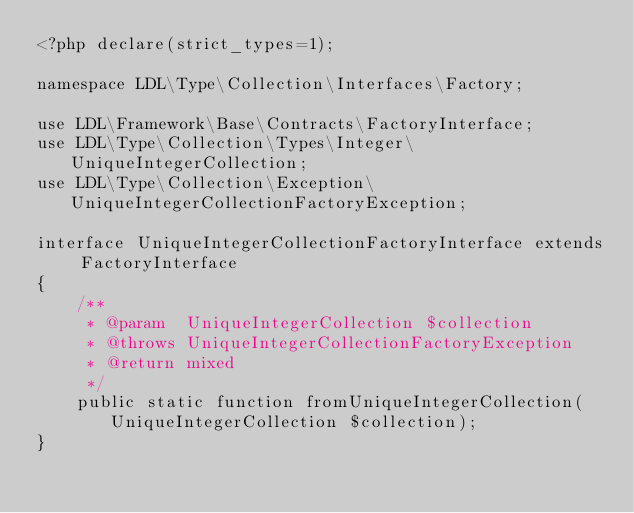<code> <loc_0><loc_0><loc_500><loc_500><_PHP_><?php declare(strict_types=1);

namespace LDL\Type\Collection\Interfaces\Factory;

use LDL\Framework\Base\Contracts\FactoryInterface;
use LDL\Type\Collection\Types\Integer\UniqueIntegerCollection;
use LDL\Type\Collection\Exception\UniqueIntegerCollectionFactoryException;

interface UniqueIntegerCollectionFactoryInterface extends FactoryInterface
{    
    /**
     * @param  UniqueIntegerCollection $collection
     * @throws UniqueIntegerCollectionFactoryException
     * @return mixed
     */
    public static function fromUniqueIntegerCollection(UniqueIntegerCollection $collection);
}</code> 